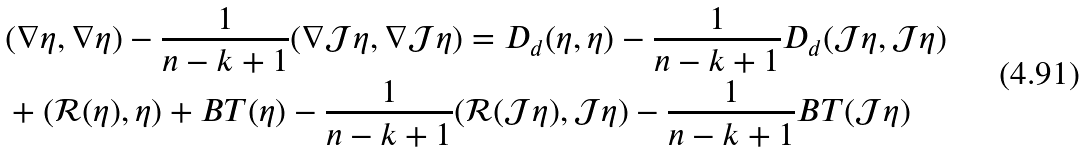Convert formula to latex. <formula><loc_0><loc_0><loc_500><loc_500>& ( \nabla \eta , \nabla \eta ) - \frac { 1 } { n - k + 1 } ( \nabla \mathcal { J } \eta , \nabla \mathcal { J } \eta ) = D _ { d } ( \eta , \eta ) - \frac { 1 } { n - k + 1 } D _ { d } ( \mathcal { J } \eta , \mathcal { J } \eta ) \\ & + ( \mathcal { R } ( \eta ) , \eta ) + B T ( \eta ) - \frac { 1 } { n - k + 1 } ( \mathcal { R } ( \mathcal { J } \eta ) , \mathcal { J } \eta ) - \frac { 1 } { n - k + 1 } B T ( \mathcal { J } \eta )</formula> 